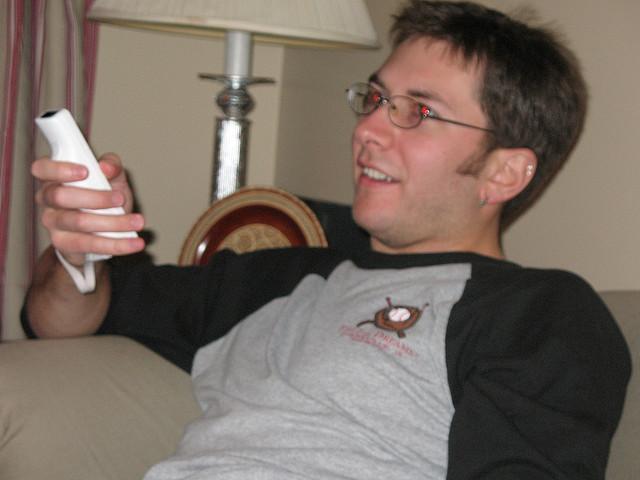How many remotes are in the photo?
Give a very brief answer. 1. How many couches are there?
Give a very brief answer. 1. 